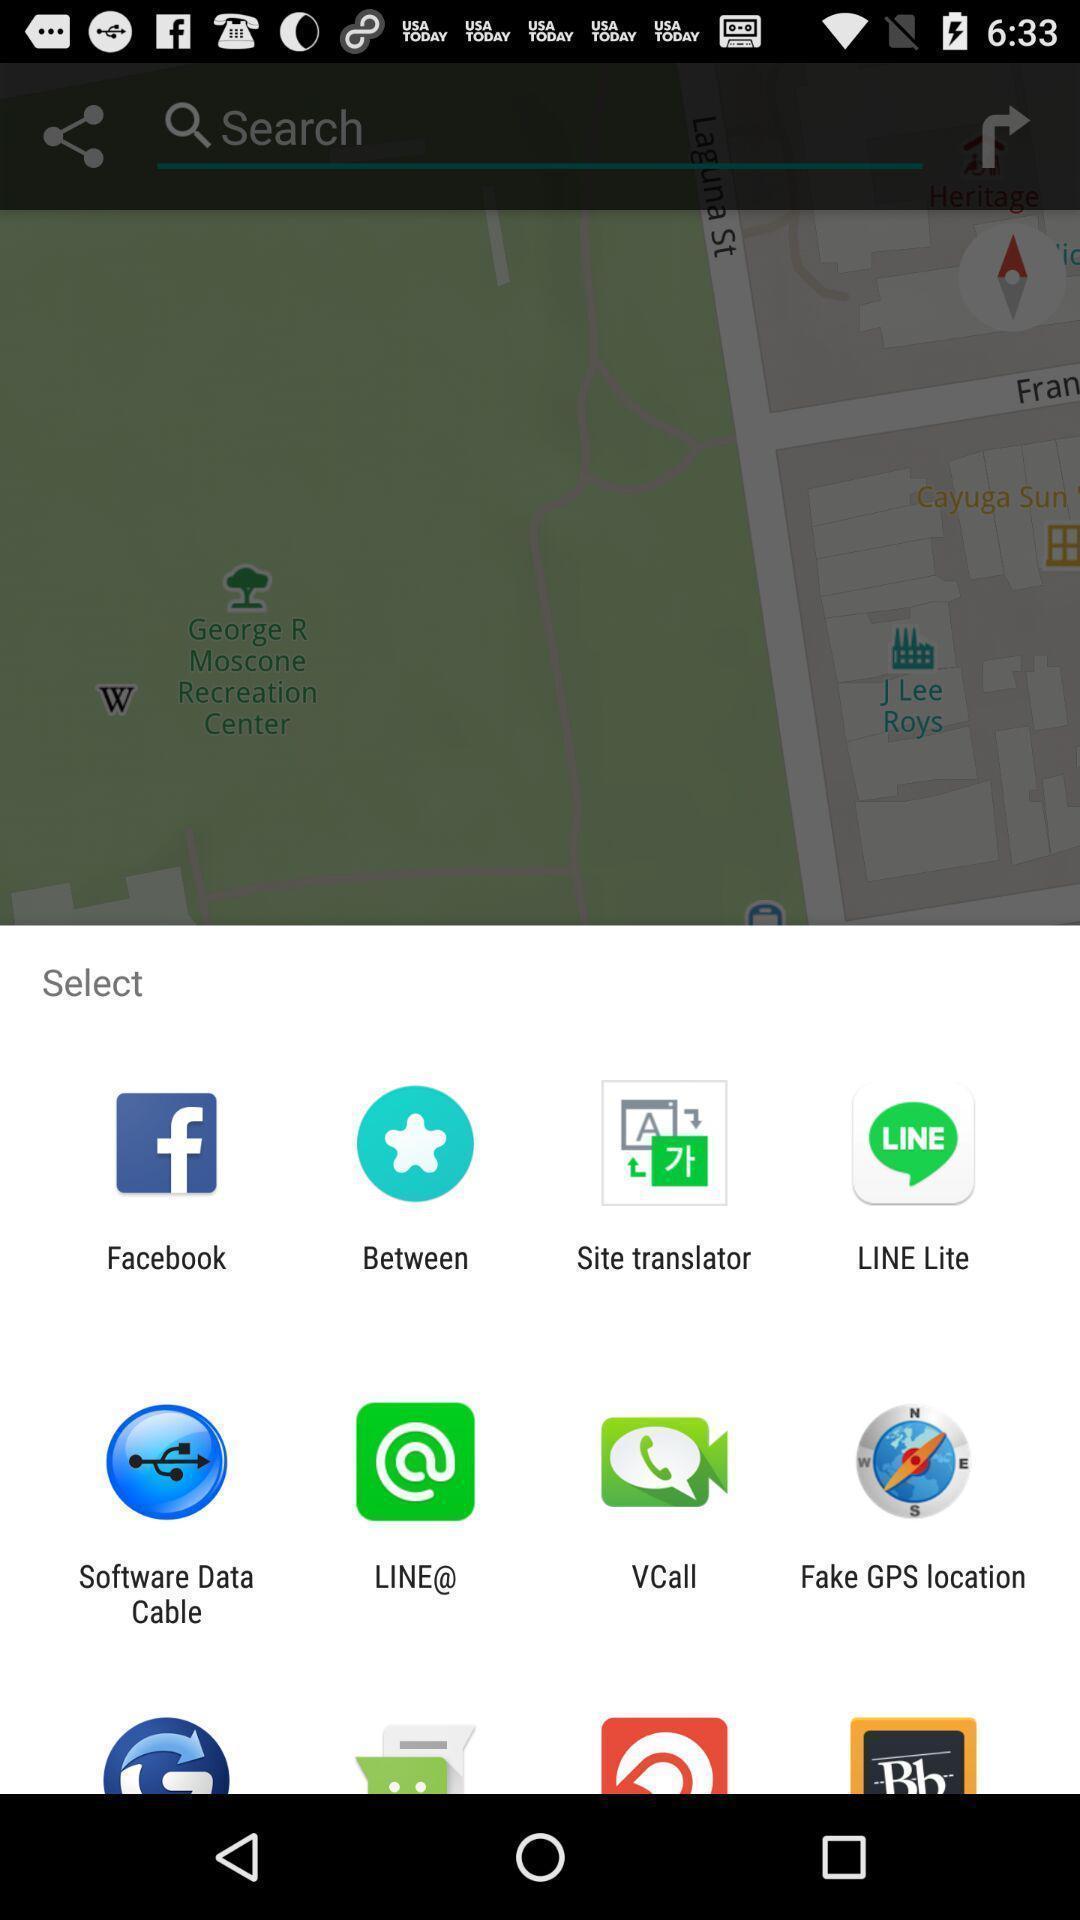Tell me what you see in this picture. Popup showing different options to share the file. 